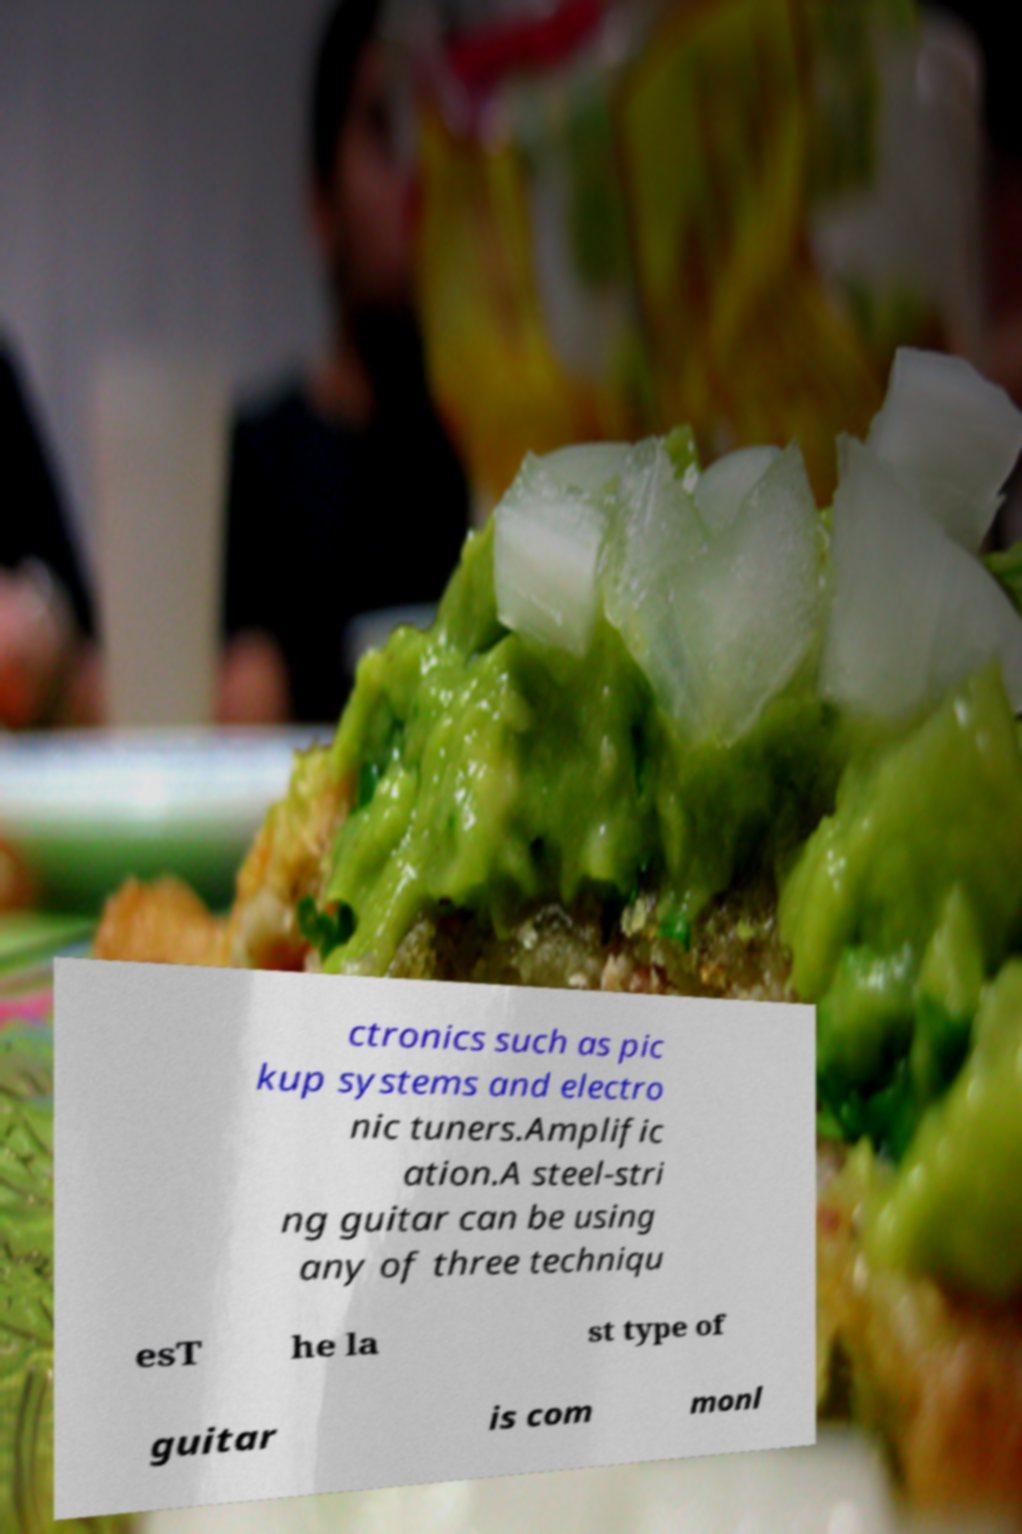Please identify and transcribe the text found in this image. ctronics such as pic kup systems and electro nic tuners.Amplific ation.A steel-stri ng guitar can be using any of three techniqu esT he la st type of guitar is com monl 